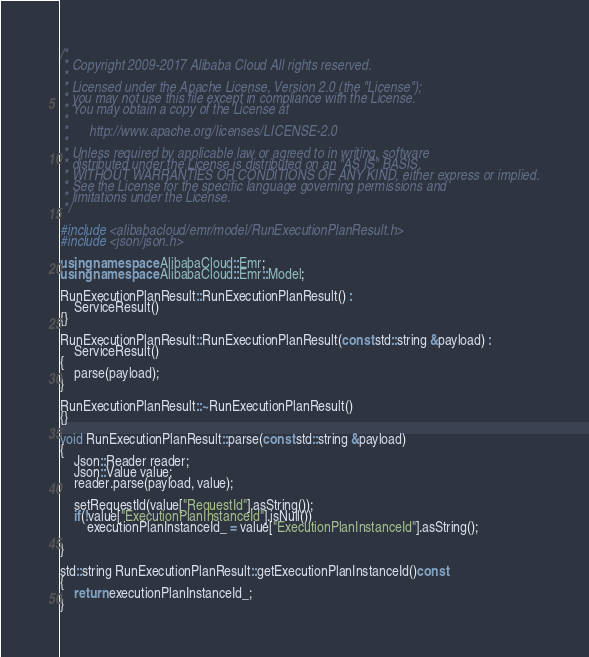Convert code to text. <code><loc_0><loc_0><loc_500><loc_500><_C++_>/*
 * Copyright 2009-2017 Alibaba Cloud All rights reserved.
 * 
 * Licensed under the Apache License, Version 2.0 (the "License");
 * you may not use this file except in compliance with the License.
 * You may obtain a copy of the License at
 * 
 *      http://www.apache.org/licenses/LICENSE-2.0
 * 
 * Unless required by applicable law or agreed to in writing, software
 * distributed under the License is distributed on an "AS IS" BASIS,
 * WITHOUT WARRANTIES OR CONDITIONS OF ANY KIND, either express or implied.
 * See the License for the specific language governing permissions and
 * limitations under the License.
 */

#include <alibabacloud/emr/model/RunExecutionPlanResult.h>
#include <json/json.h>

using namespace AlibabaCloud::Emr;
using namespace AlibabaCloud::Emr::Model;

RunExecutionPlanResult::RunExecutionPlanResult() :
	ServiceResult()
{}

RunExecutionPlanResult::RunExecutionPlanResult(const std::string &payload) :
	ServiceResult()
{
	parse(payload);
}

RunExecutionPlanResult::~RunExecutionPlanResult()
{}

void RunExecutionPlanResult::parse(const std::string &payload)
{
	Json::Reader reader;
	Json::Value value;
	reader.parse(payload, value);

	setRequestId(value["RequestId"].asString());
	if(!value["ExecutionPlanInstanceId"].isNull())
		executionPlanInstanceId_ = value["ExecutionPlanInstanceId"].asString();

}

std::string RunExecutionPlanResult::getExecutionPlanInstanceId()const
{
	return executionPlanInstanceId_;
}

</code> 